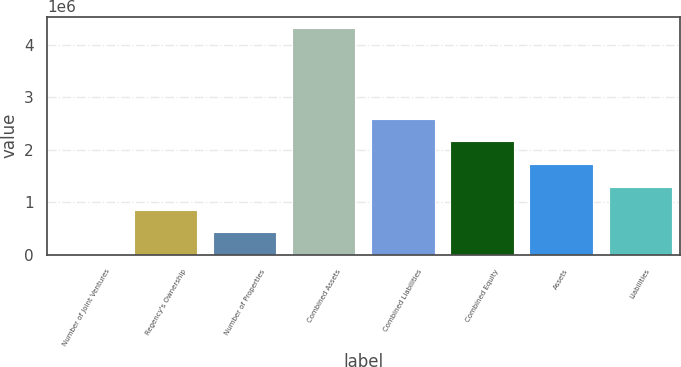Convert chart. <chart><loc_0><loc_0><loc_500><loc_500><bar_chart><fcel>Number of Joint Ventures<fcel>Regency's Ownership<fcel>Number of Properties<fcel>Combined Assets<fcel>Combined Liabilities<fcel>Combined Equity<fcel>Assets<fcel>Liabilities<nl><fcel>15<fcel>863728<fcel>431872<fcel>4.31858e+06<fcel>2.59115e+06<fcel>2.1593e+06<fcel>1.72744e+06<fcel>1.29558e+06<nl></chart> 